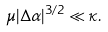<formula> <loc_0><loc_0><loc_500><loc_500>\mu | \Delta \alpha | ^ { 3 / 2 } \ll \kappa .</formula> 